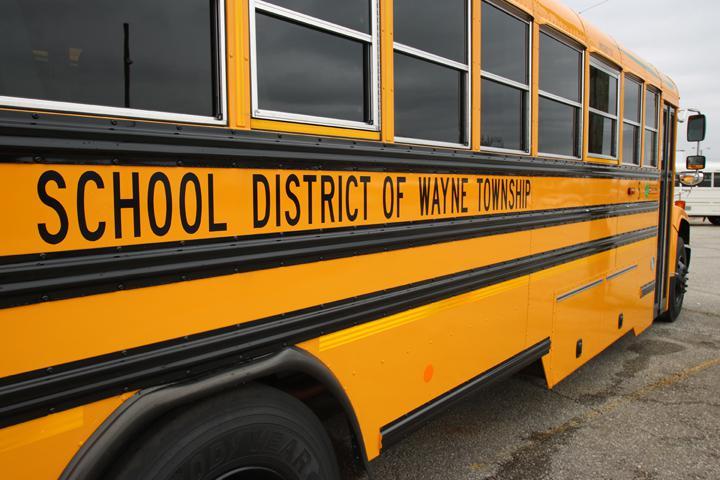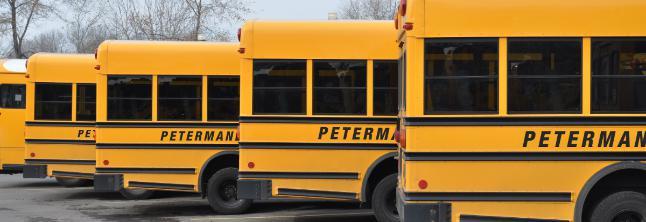The first image is the image on the left, the second image is the image on the right. For the images displayed, is the sentence "There are more buses in the right image than in the left image." factually correct? Answer yes or no. Yes. The first image is the image on the left, the second image is the image on the right. Examine the images to the left and right. Is the description "An image shows one horizontal bus with closed passenger doors at the right." accurate? Answer yes or no. No. 